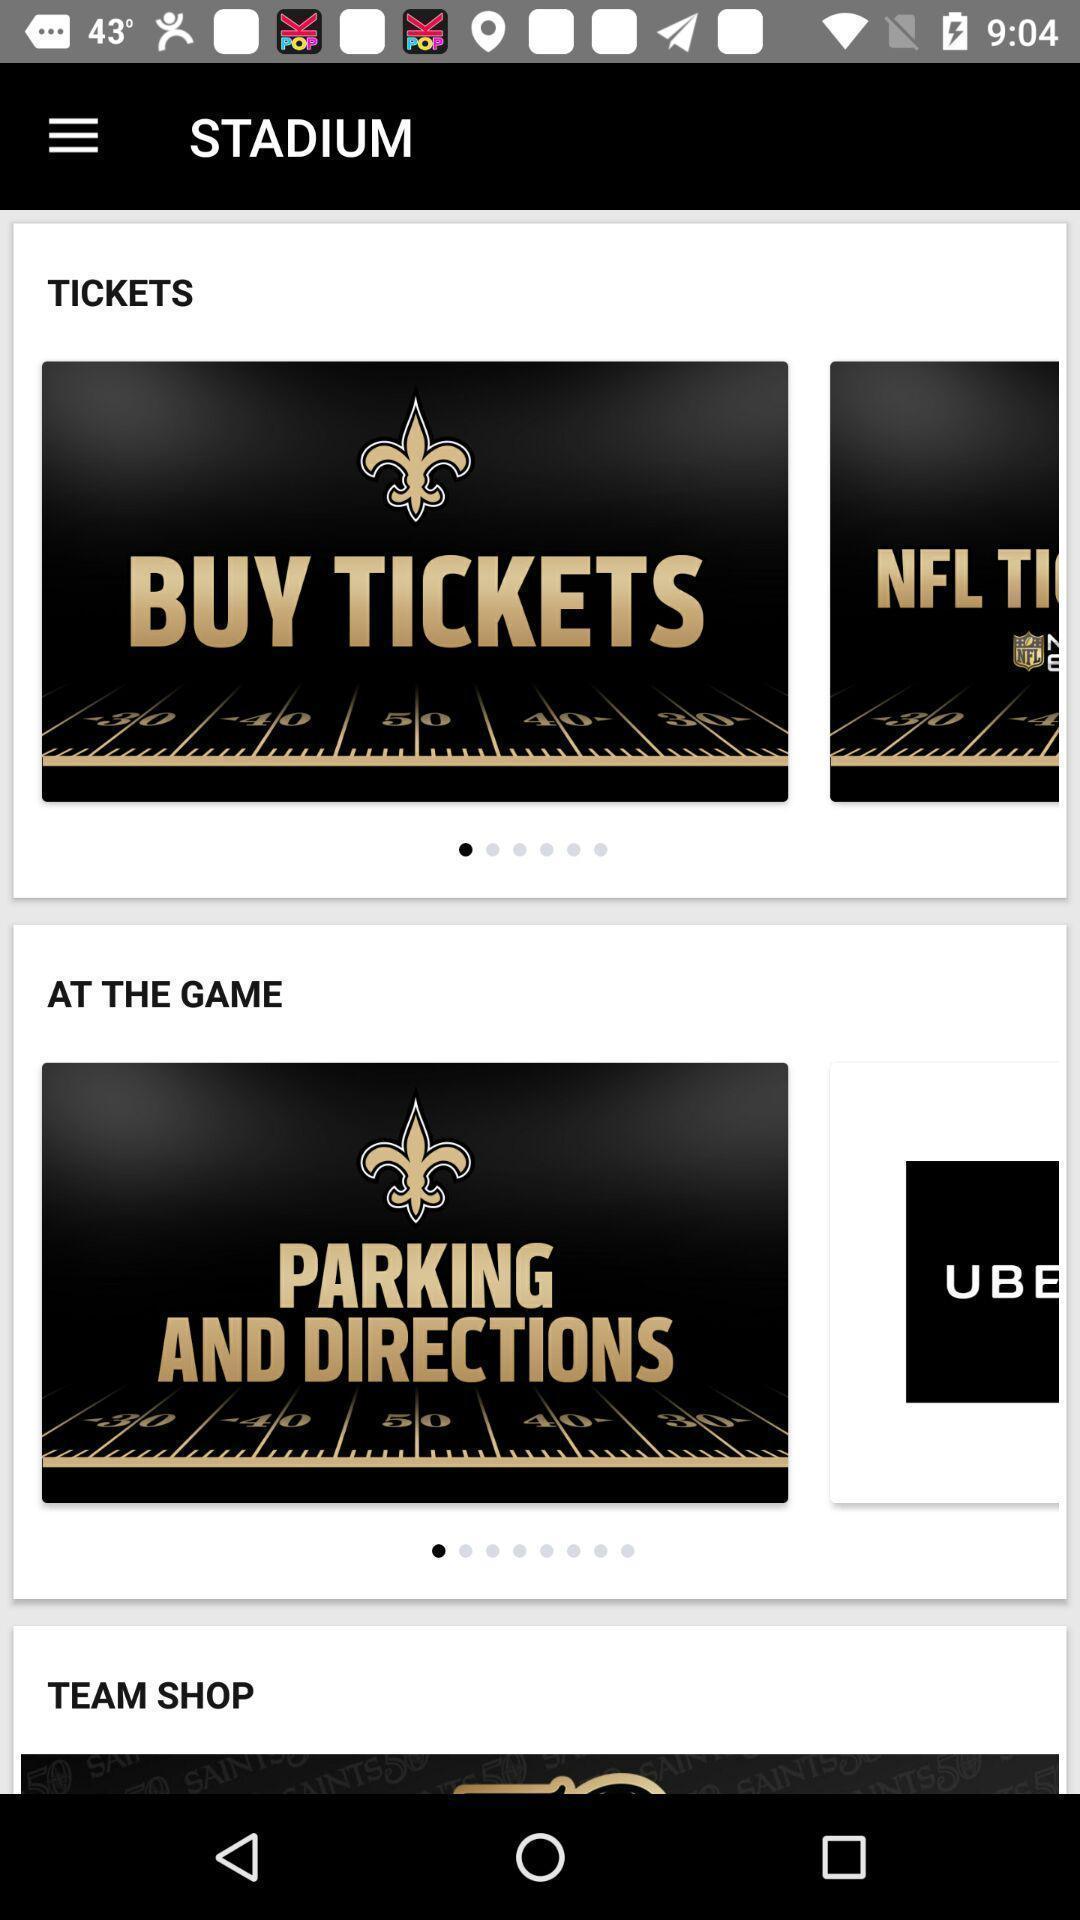Explain what's happening in this screen capture. Page showing options for a sports team. 